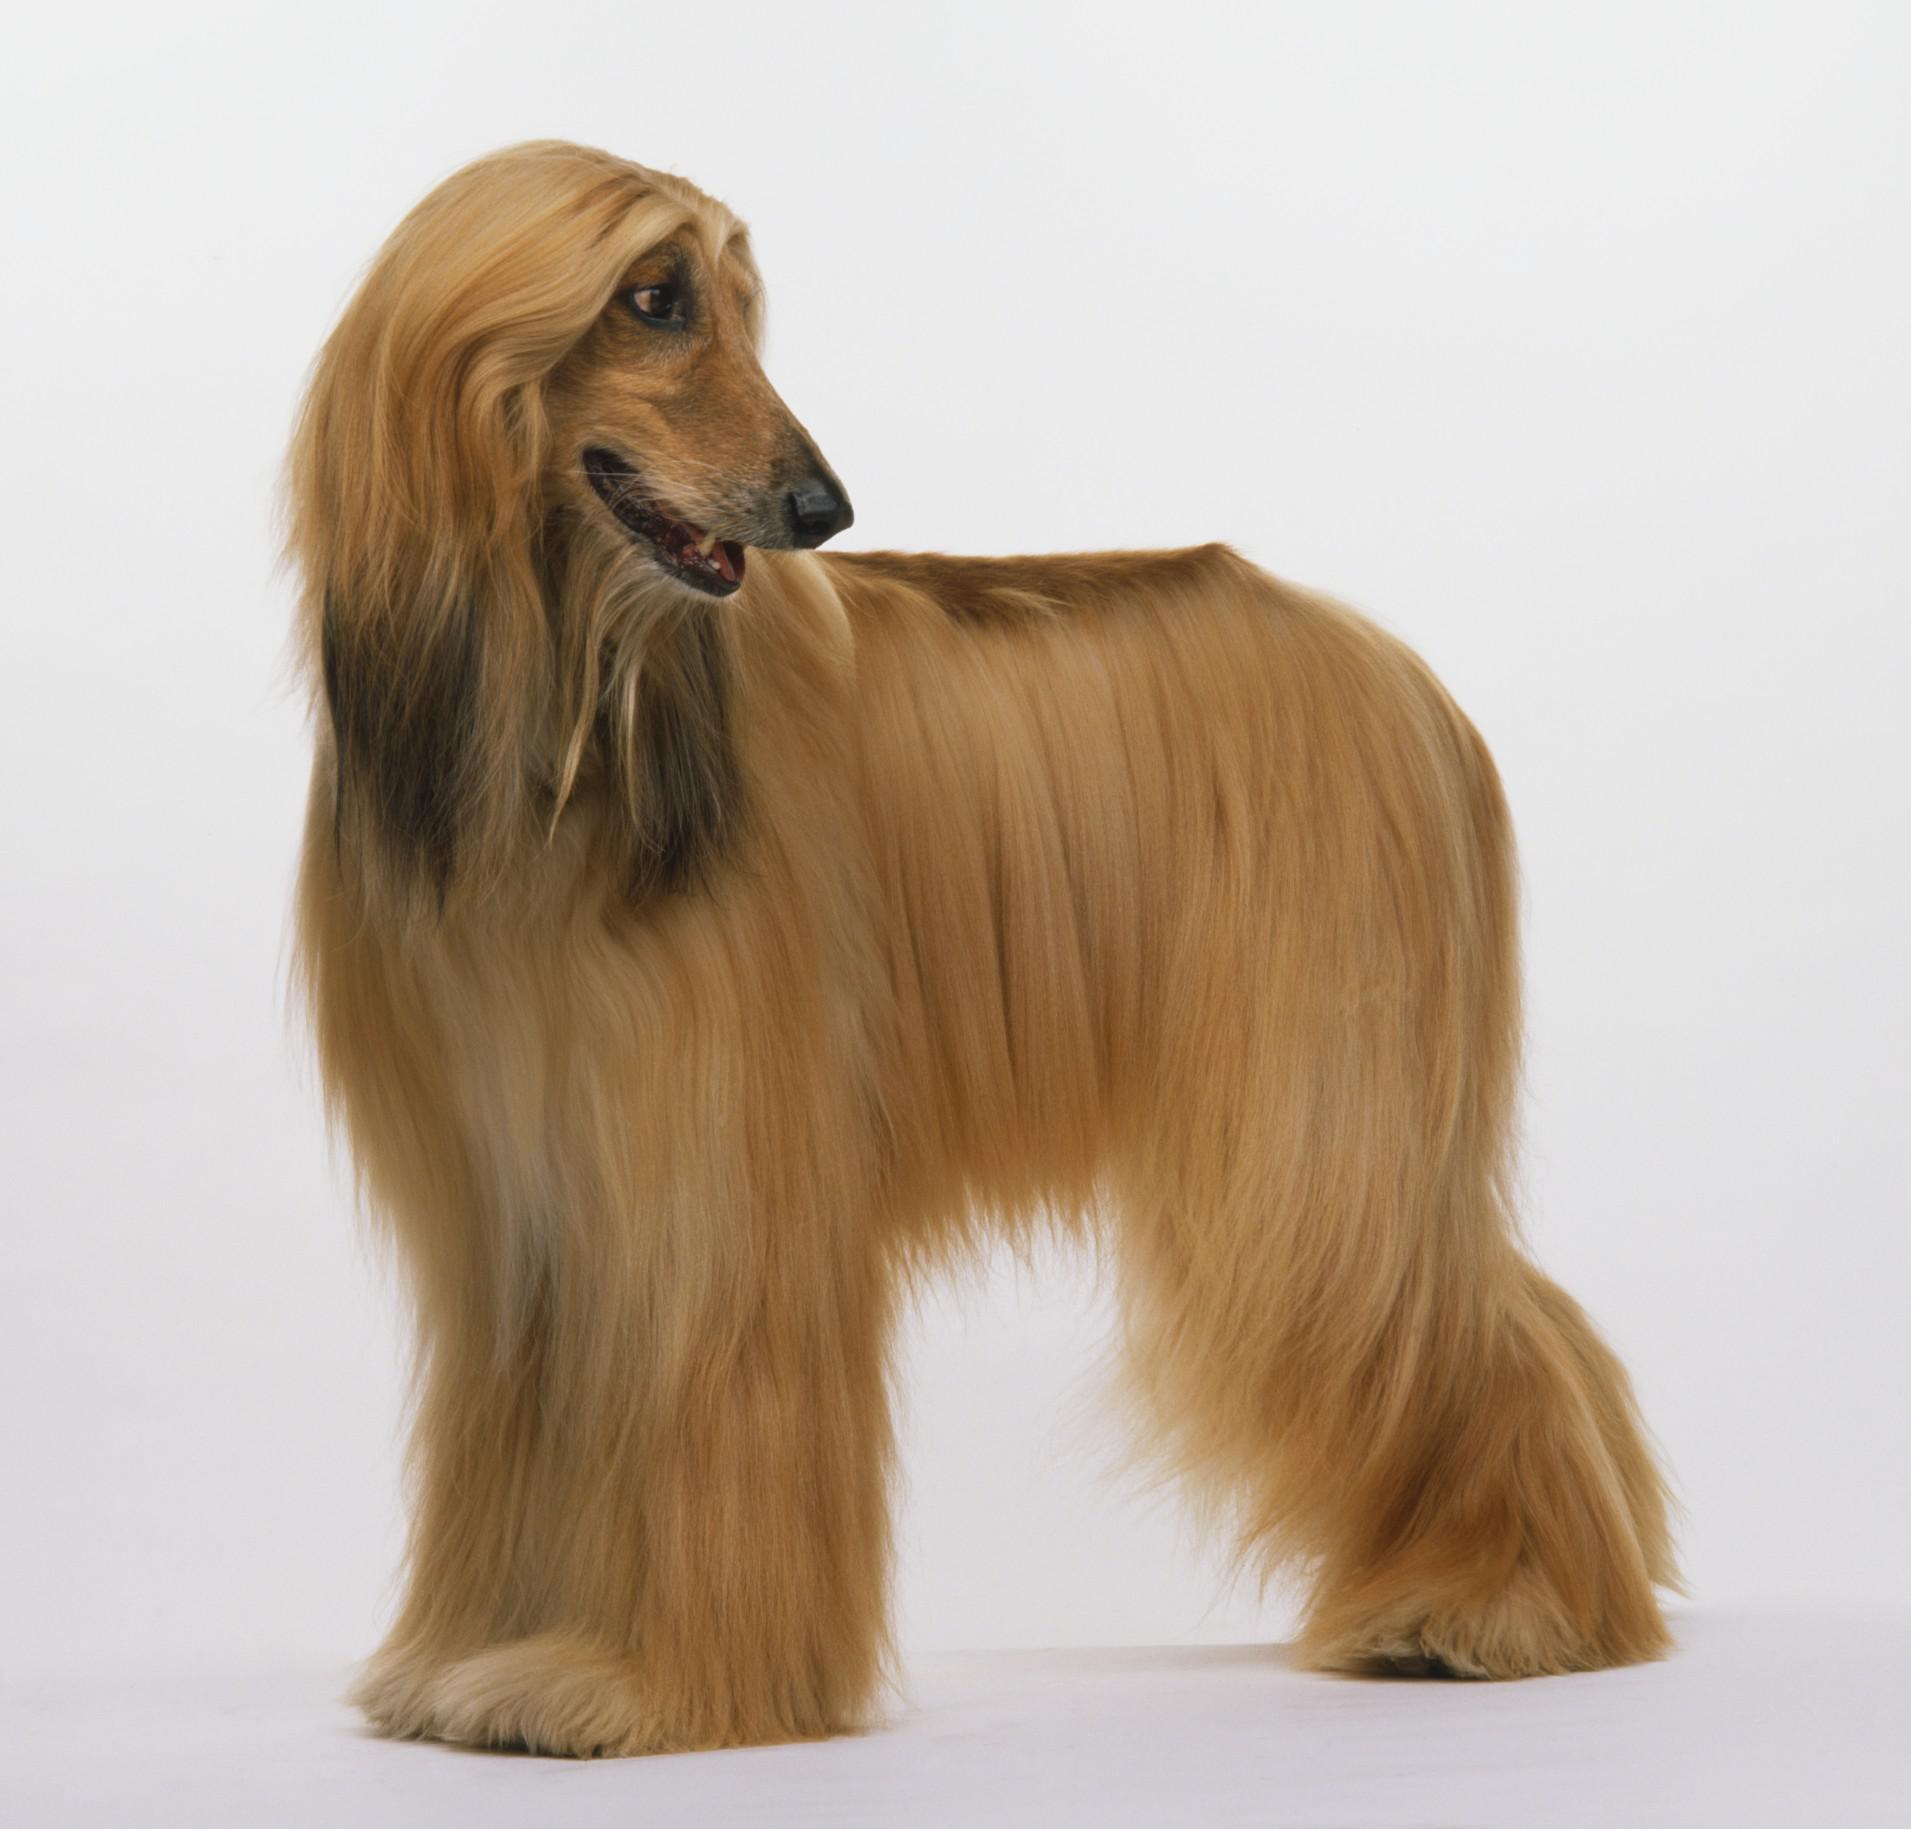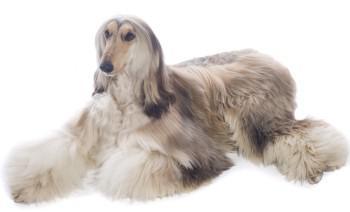The first image is the image on the left, the second image is the image on the right. For the images displayed, is the sentence "The hound on the left is more golden brown, and the one on the right is more cream colored." factually correct? Answer yes or no. Yes. 